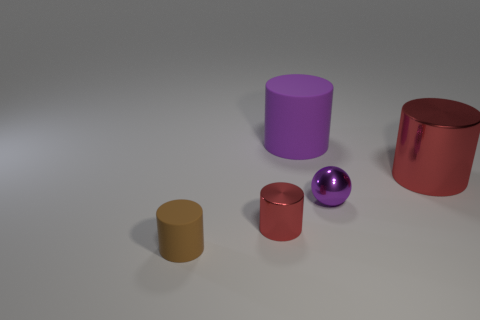Subtract all purple cylinders. How many cylinders are left? 3 Subtract 1 cylinders. How many cylinders are left? 3 Subtract all cyan cylinders. Subtract all green cubes. How many cylinders are left? 4 Add 4 matte things. How many objects exist? 9 Subtract all cylinders. How many objects are left? 1 Subtract 0 green cylinders. How many objects are left? 5 Subtract all tiny brown things. Subtract all matte cylinders. How many objects are left? 2 Add 1 red metallic cylinders. How many red metallic cylinders are left? 3 Add 1 cylinders. How many cylinders exist? 5 